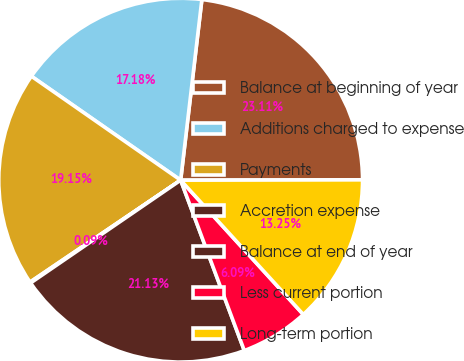<chart> <loc_0><loc_0><loc_500><loc_500><pie_chart><fcel>Balance at beginning of year<fcel>Additions charged to expense<fcel>Payments<fcel>Accretion expense<fcel>Balance at end of year<fcel>Less current portion<fcel>Long-term portion<nl><fcel>23.11%<fcel>17.18%<fcel>19.15%<fcel>0.09%<fcel>21.13%<fcel>6.09%<fcel>13.25%<nl></chart> 